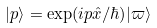<formula> <loc_0><loc_0><loc_500><loc_500>| p \rangle = \exp ( i p { \hat { x } } / \hbar { ) } | \varpi \rangle</formula> 